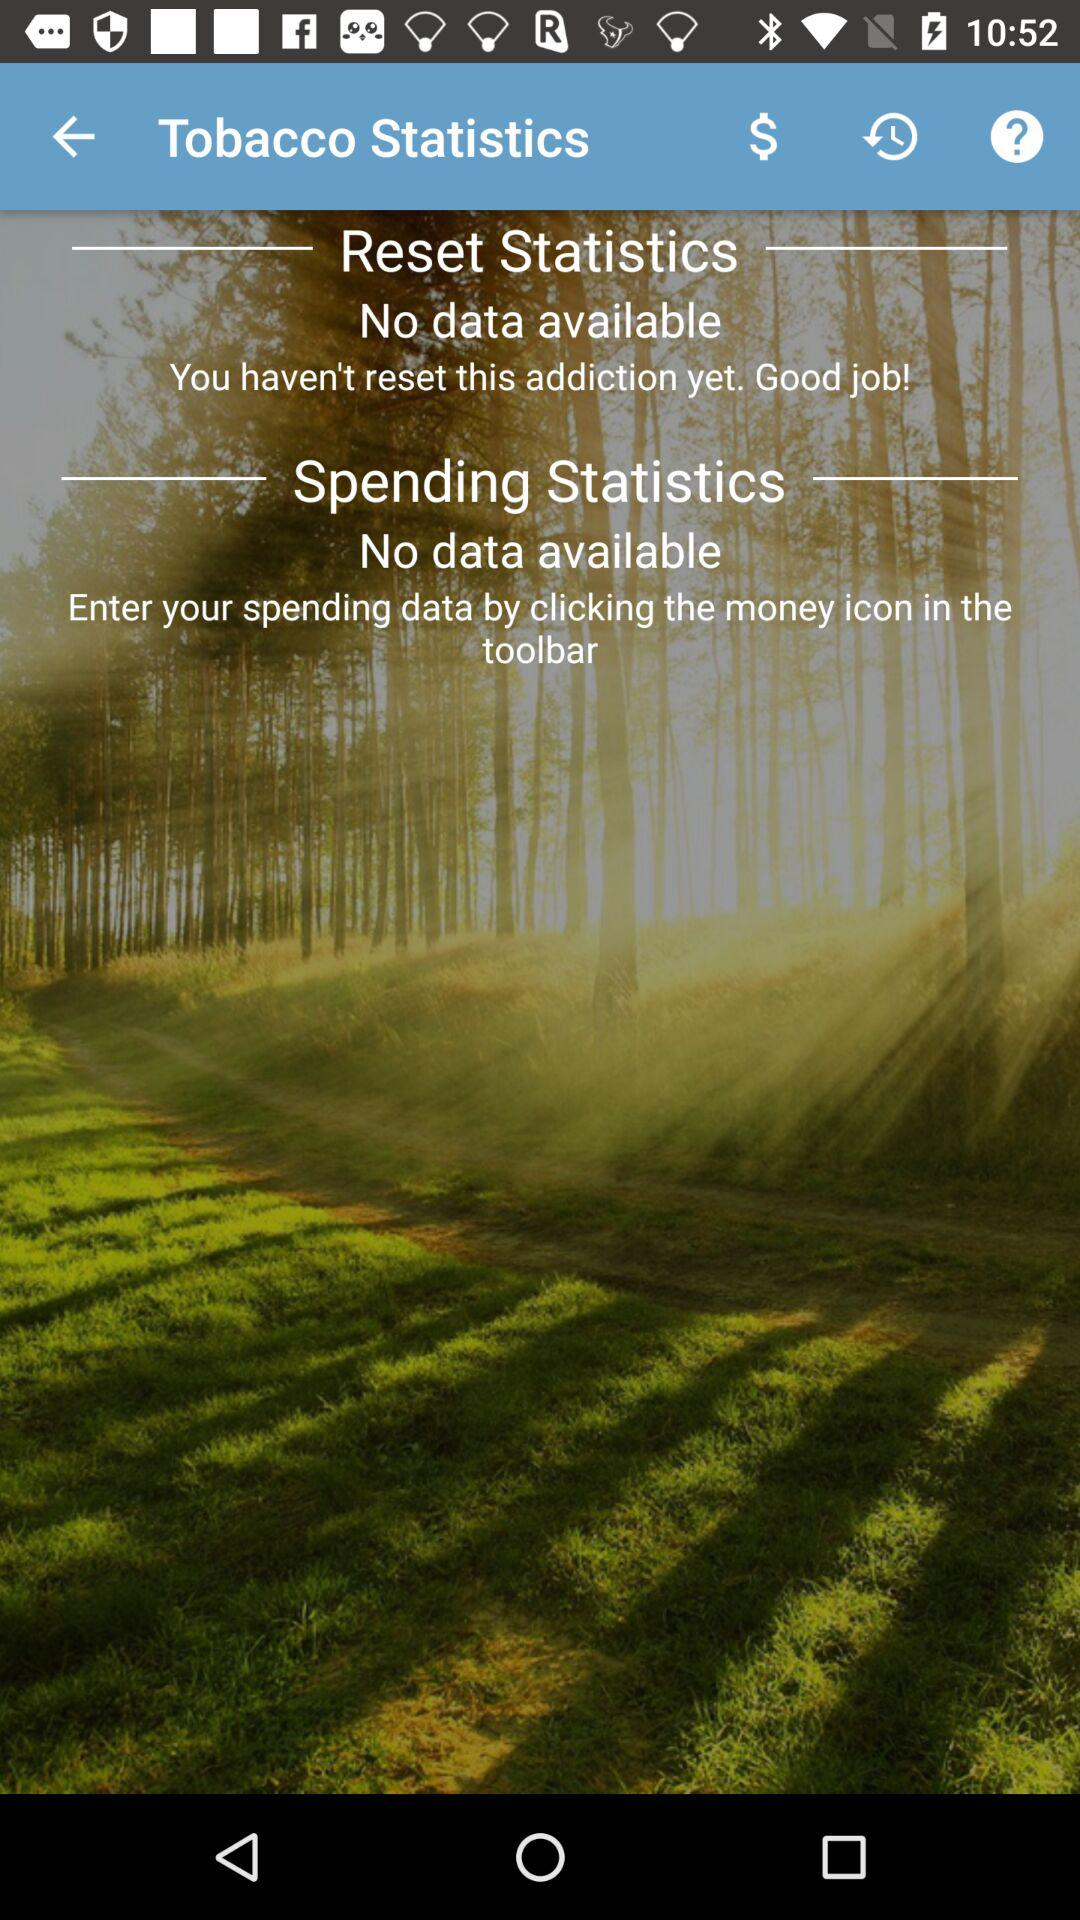Can you explain what might be the reason for the 'No data available' message in both statistics? The 'No data available' message suggests that the user has not yet input any data related to tobacco usage or spending. This could be because they've only recently started using the app, or they may have successfully avoided tobacco, thus leading to no spending to track. If I want to add my data, what steps should I follow? To add your data, you should click on the money icon in the app's toolbar as instructed on the screen. This action should lead you to a section where you can input your spending information, and that data will be then reflected in your personal statistics. 